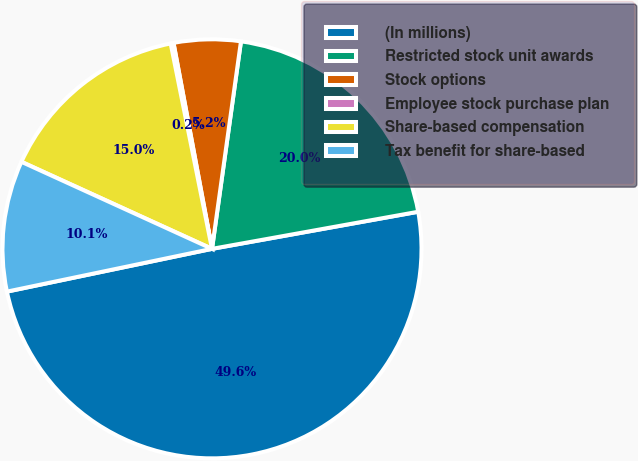Convert chart to OTSL. <chart><loc_0><loc_0><loc_500><loc_500><pie_chart><fcel>(In millions)<fcel>Restricted stock unit awards<fcel>Stock options<fcel>Employee stock purchase plan<fcel>Share-based compensation<fcel>Tax benefit for share-based<nl><fcel>49.56%<fcel>19.96%<fcel>5.15%<fcel>0.22%<fcel>15.02%<fcel>10.09%<nl></chart> 